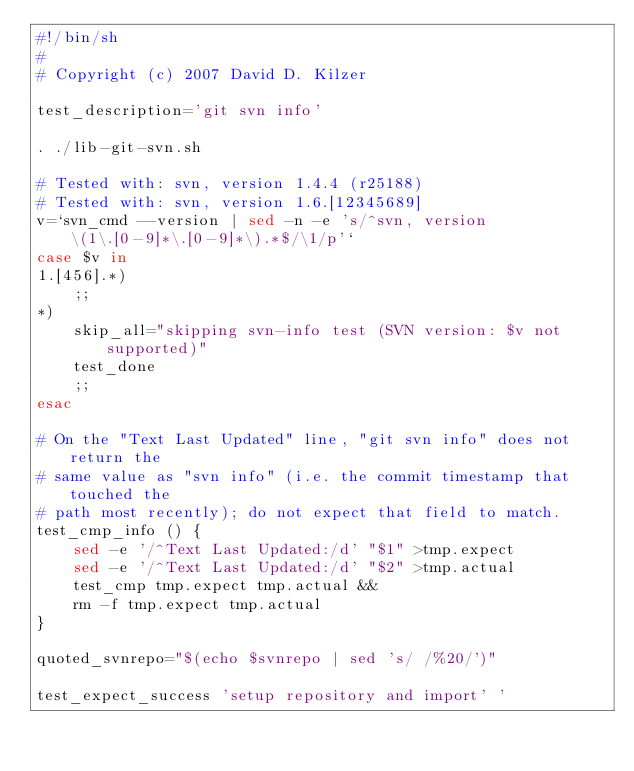<code> <loc_0><loc_0><loc_500><loc_500><_Bash_>#!/bin/sh
#
# Copyright (c) 2007 David D. Kilzer

test_description='git svn info'

. ./lib-git-svn.sh

# Tested with: svn, version 1.4.4 (r25188)
# Tested with: svn, version 1.6.[12345689]
v=`svn_cmd --version | sed -n -e 's/^svn, version \(1\.[0-9]*\.[0-9]*\).*$/\1/p'`
case $v in
1.[456].*)
	;;
*)
	skip_all="skipping svn-info test (SVN version: $v not supported)"
	test_done
	;;
esac

# On the "Text Last Updated" line, "git svn info" does not return the
# same value as "svn info" (i.e. the commit timestamp that touched the
# path most recently); do not expect that field to match.
test_cmp_info () {
	sed -e '/^Text Last Updated:/d' "$1" >tmp.expect
	sed -e '/^Text Last Updated:/d' "$2" >tmp.actual
	test_cmp tmp.expect tmp.actual &&
	rm -f tmp.expect tmp.actual
}

quoted_svnrepo="$(echo $svnrepo | sed 's/ /%20/')"

test_expect_success 'setup repository and import' '</code> 